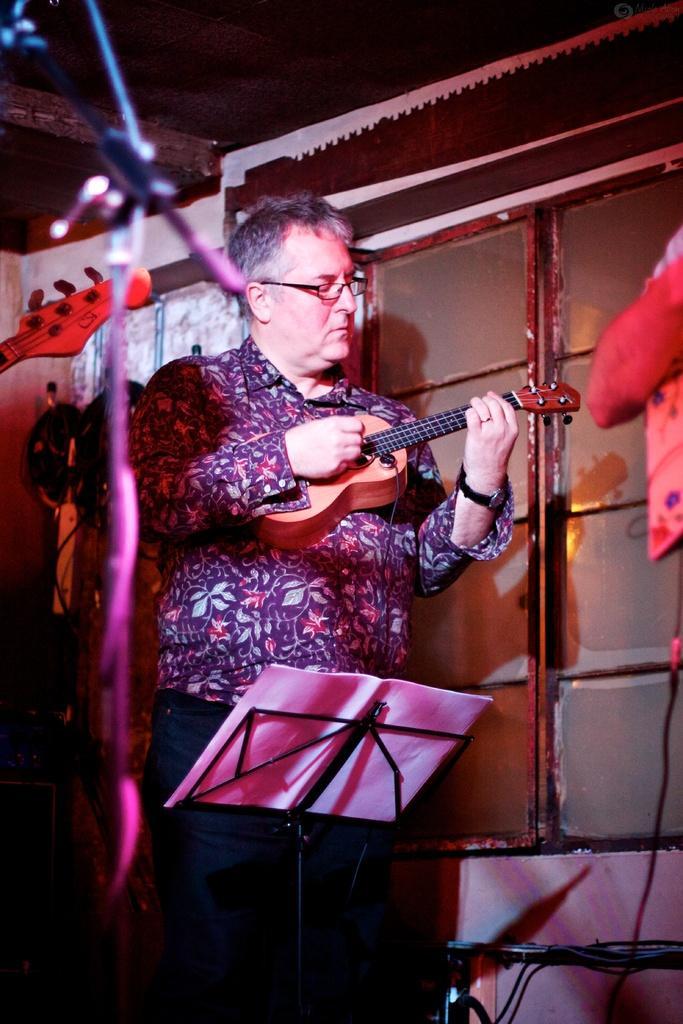In one or two sentences, can you explain what this image depicts? There is a man standing in the center and he is holding a guitar in his hand. 